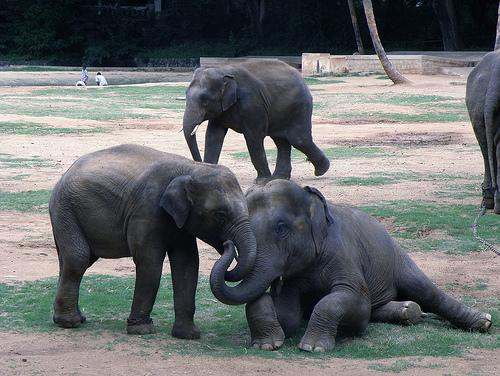Illustrate the central concept of the image by mentioning the fundamental components and their actions. The image captures an elephant laying down in a lively scene filled with other elephants, people at a distance, and a grassy, earthen field. Summarize the main scene in the photograph and mention some essential details. The image depicts elephants, one of which is laying down, with others interacting in a grassy field; people are also present in the background near a curved palm tree trunk. Describe the primary subject of the photograph and its immediate environment. A laying-down elephant is the focal point, surrounded by other elephants interacting, people in the distance, and a mix of grass and dirt in the field. Outline the main content of the image concisely, including what actions are taking place. The image contains a laying-down elephant, other interacting elephants, people observing from afar, and a grassy, dirt-filled field setting. Provide a brief description of the primary elements and their actions in the picture. An elephant is laying down in a field, surrounded by other elephants playing and walking, with people standing in the distance and a palm tree nearby. Deliver a brief narrative of the central theme in the photograph and its components. In the picture, an elephant lays down amidst a lively scene of other elephants engaging with each other, people spectating, and a field with varied vegetation. Sum up the essential information about the photo, including the subject and environment. The picture portrays a laying-down elephant within a dynamic setting of other elephants, observing people, and a field containing grass and dirt. Mention the crucial features of the scene and their main activity. The key aspect is an elephant laying down, with additional elements like playing elephants, distant people, and a palm tree contributing to the atmosphere. Characterize the central focus of the image and its surroundings succinctly. Elephants, particularly one laying down, engage in a vibrant outdoor scene, amidst other elephants, people, and various landscape elements. Offer a succinct representation of the prominent elements and their ongoing activities in the photograph. The photo features a laying-down elephant, surrounded by other elephants in action, far-off people, and a field with mixed vegetation. 